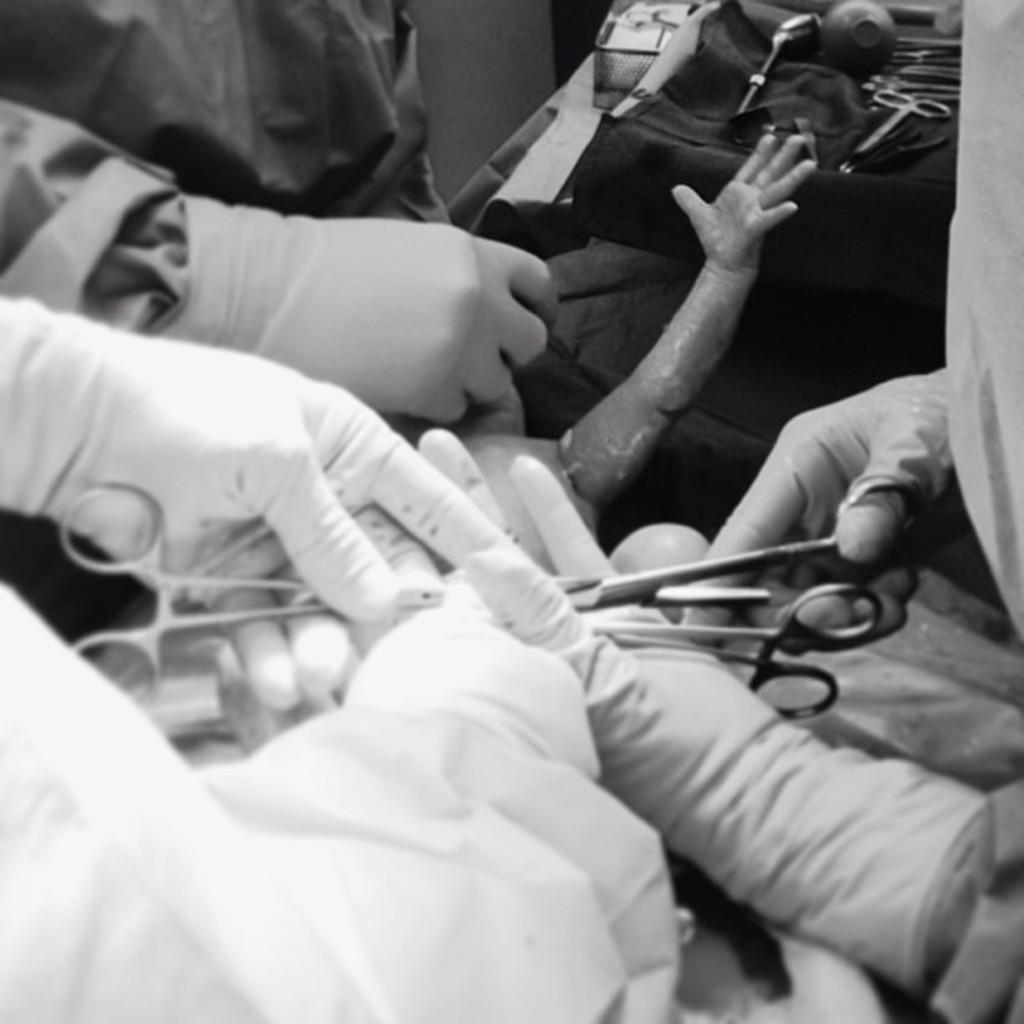Describe this image in one or two sentences. In this image we can see some persons hands who are wearing gloves and holding scissors in their hands and we can see a kid's hand, on right side of the image there are scissors, some things are in a tray. 